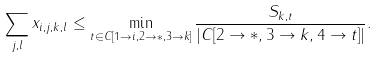<formula> <loc_0><loc_0><loc_500><loc_500>\sum _ { j , l } x _ { i , j , k , l } \leq \min _ { t \in C [ 1 \rightarrow i , 2 \rightarrow * , 3 \rightarrow k ] } \frac { S _ { k , t } } { | C [ 2 \rightarrow * , 3 \rightarrow k , 4 \rightarrow t ] | } .</formula> 